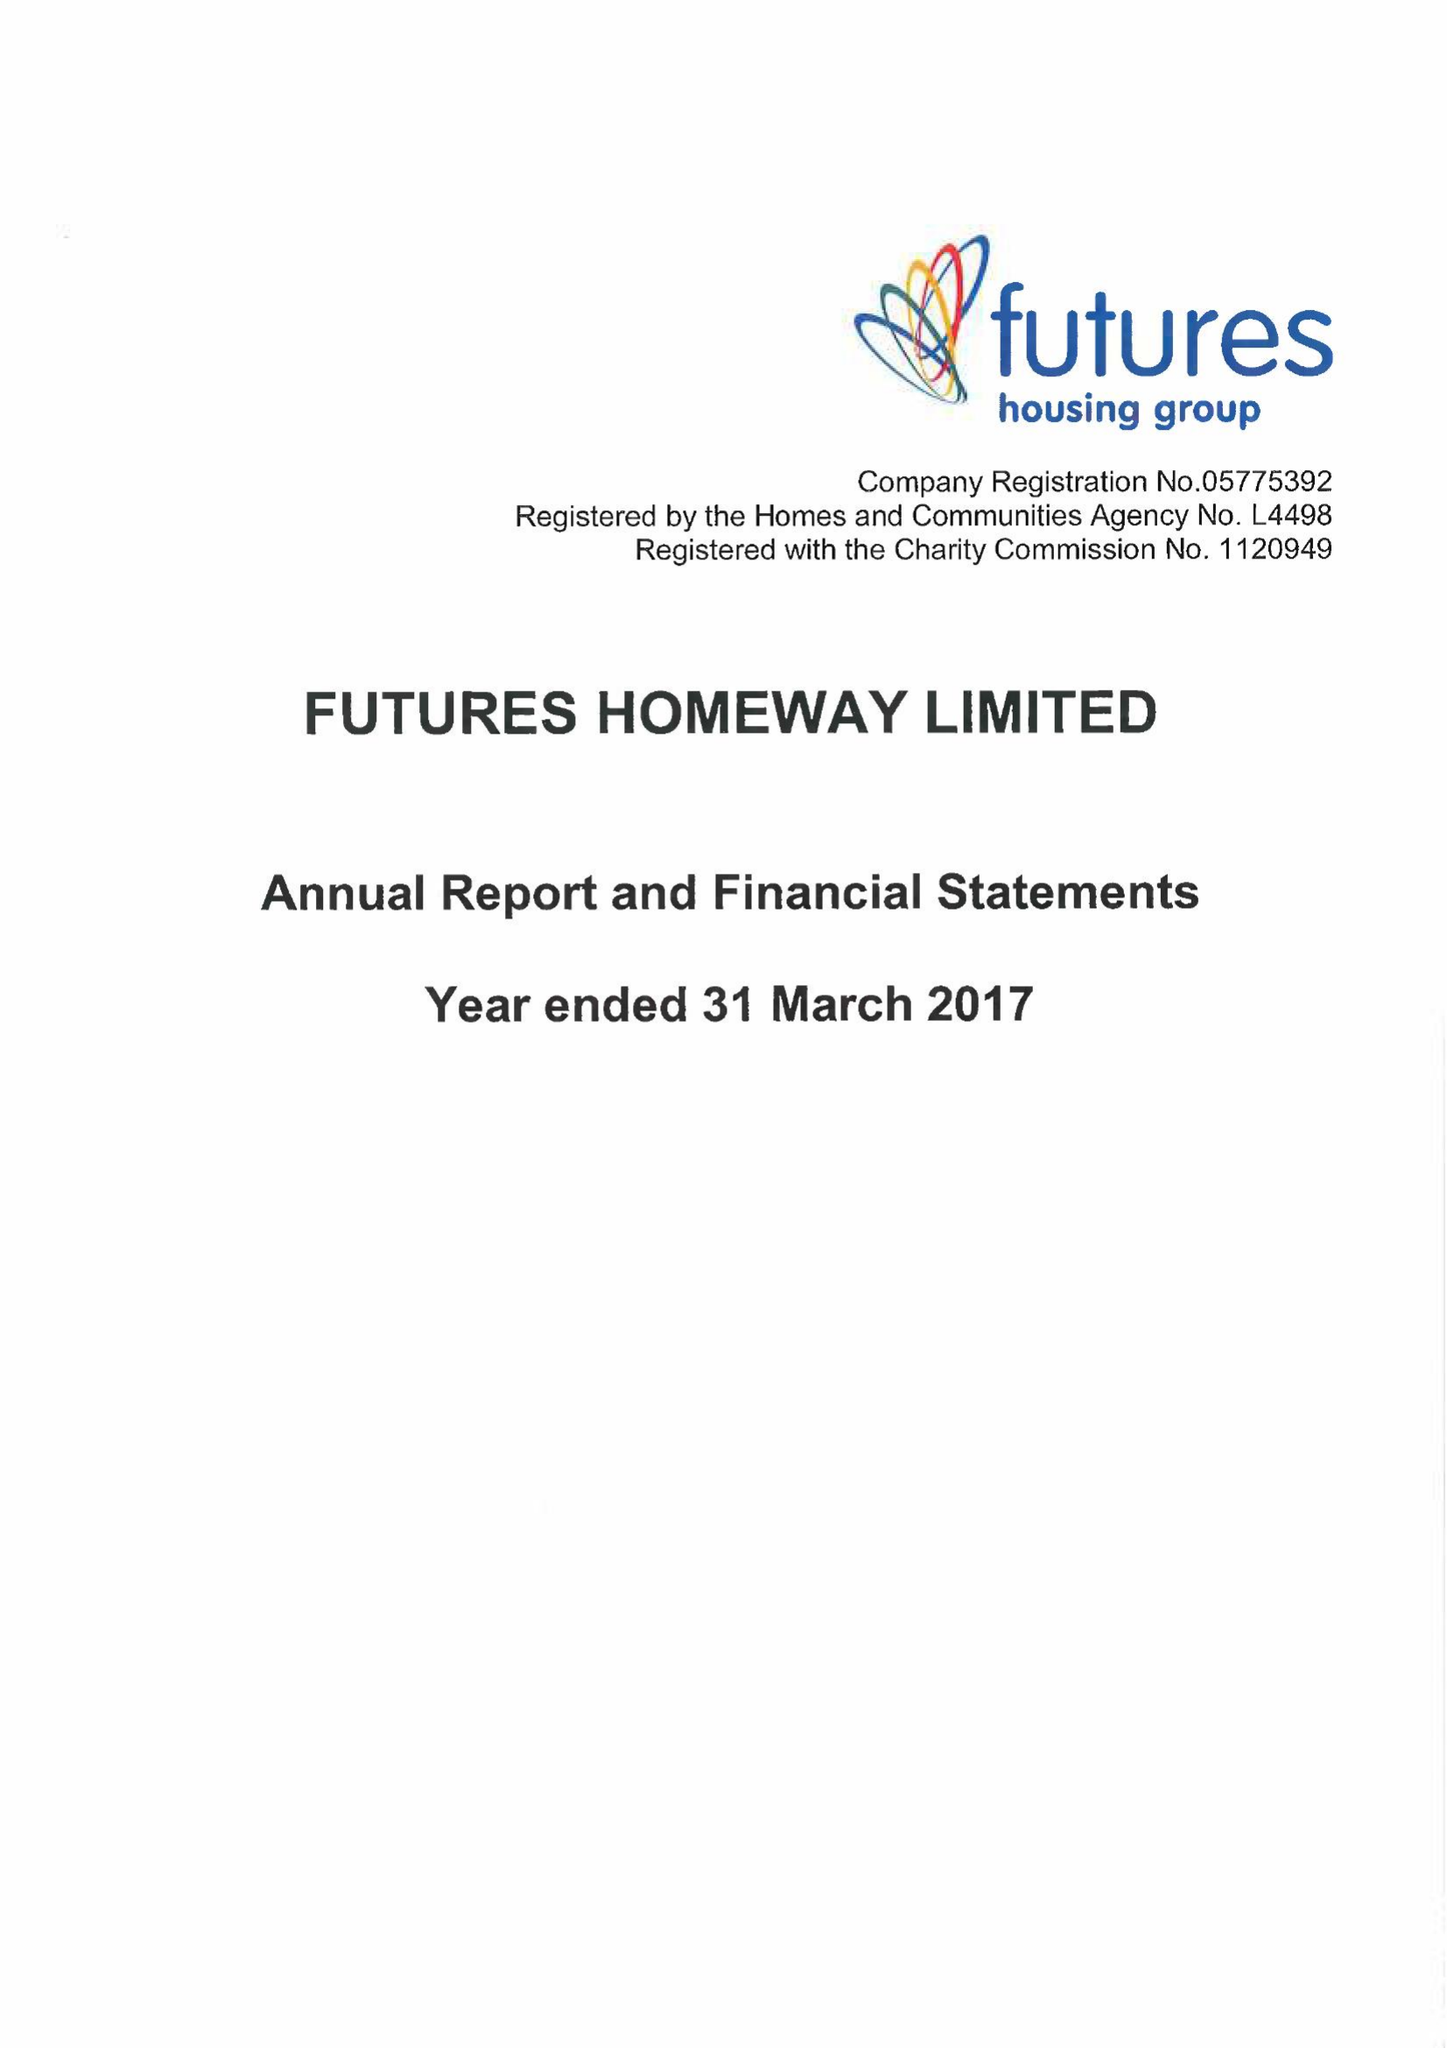What is the value for the address__postcode?
Answer the question using a single word or phrase. DE5 3SW 